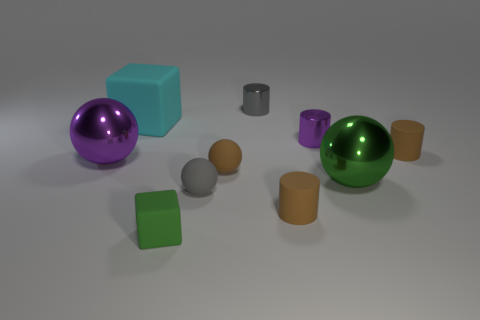There is a large metallic sphere on the left side of the gray cylinder; what number of small cylinders are in front of it?
Provide a succinct answer. 1. What number of green things are both on the right side of the small gray metallic cylinder and in front of the gray rubber sphere?
Provide a succinct answer. 0. How many things are either objects that are left of the small gray metallic object or cyan cubes on the left side of the tiny purple cylinder?
Give a very brief answer. 5. What number of other objects are there of the same size as the cyan matte object?
Give a very brief answer. 2. What shape is the tiny matte thing behind the purple thing on the left side of the tiny gray cylinder?
Give a very brief answer. Cylinder. There is a block that is behind the big green thing; is its color the same as the big metallic sphere right of the green rubber cube?
Offer a very short reply. No. Are there any other things that are the same color as the big cube?
Give a very brief answer. No. The small cube is what color?
Ensure brevity in your answer.  Green. Is there a small rubber ball?
Keep it short and to the point. Yes. Are there any big blocks to the left of the purple metallic ball?
Ensure brevity in your answer.  No. 